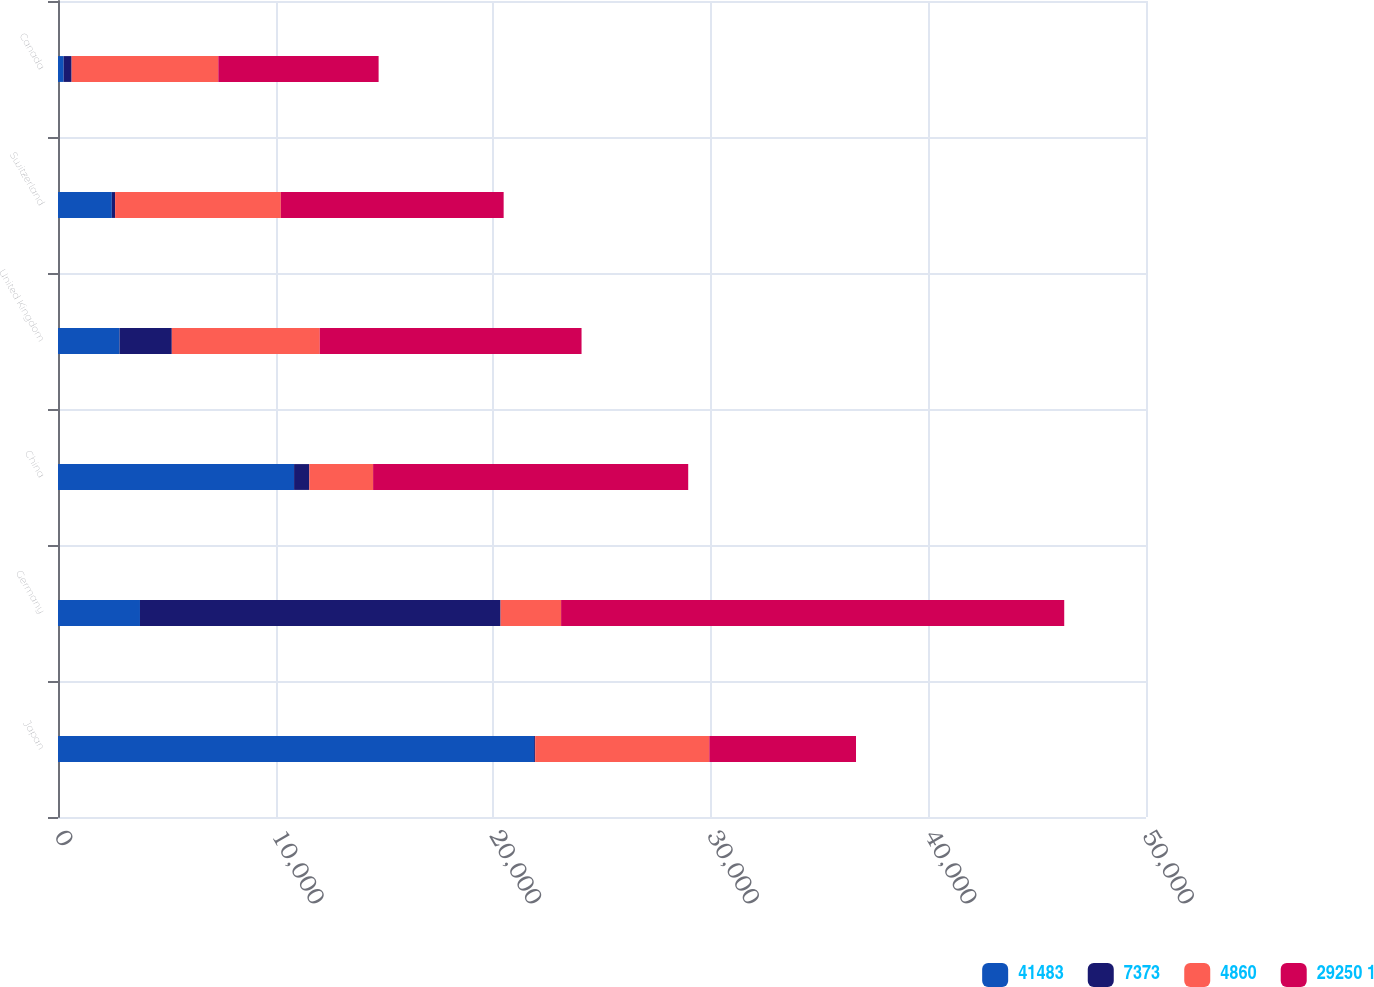<chart> <loc_0><loc_0><loc_500><loc_500><stacked_bar_chart><ecel><fcel>Japan<fcel>Germany<fcel>China<fcel>United Kingdom<fcel>Switzerland<fcel>Canada<nl><fcel>41483<fcel>21881<fcel>3767<fcel>10849<fcel>2829<fcel>2473<fcel>260<nl><fcel>7373<fcel>49<fcel>16572<fcel>701<fcel>2401<fcel>151<fcel>366<nl><fcel>4860<fcel>8002<fcel>2782<fcel>2931<fcel>6800<fcel>7616<fcel>6741<nl><fcel>29250 1<fcel>6741<fcel>23121<fcel>14481<fcel>12030<fcel>10240<fcel>7367<nl></chart> 